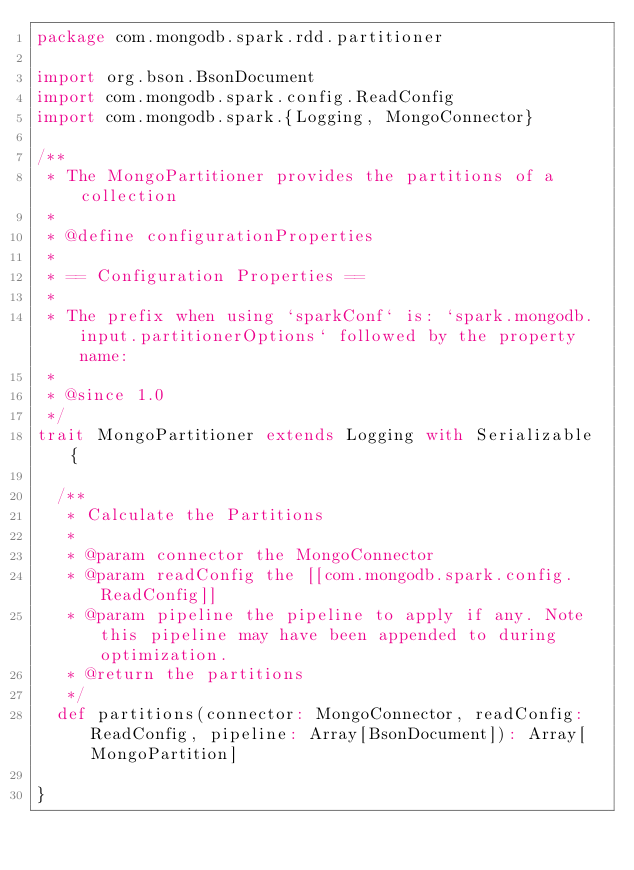<code> <loc_0><loc_0><loc_500><loc_500><_Scala_>package com.mongodb.spark.rdd.partitioner

import org.bson.BsonDocument
import com.mongodb.spark.config.ReadConfig
import com.mongodb.spark.{Logging, MongoConnector}

/**
 * The MongoPartitioner provides the partitions of a collection
 *
 * @define configurationProperties
 *
 * == Configuration Properties ==
 *
 * The prefix when using `sparkConf` is: `spark.mongodb.input.partitionerOptions` followed by the property name:
 *
 * @since 1.0
 */
trait MongoPartitioner extends Logging with Serializable {

  /**
   * Calculate the Partitions
   *
   * @param connector the MongoConnector
   * @param readConfig the [[com.mongodb.spark.config.ReadConfig]]
   * @param pipeline the pipeline to apply if any. Note this pipeline may have been appended to during optimization.
   * @return the partitions
   */
  def partitions(connector: MongoConnector, readConfig: ReadConfig, pipeline: Array[BsonDocument]): Array[MongoPartition]

}
</code> 